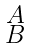Convert formula to latex. <formula><loc_0><loc_0><loc_500><loc_500>\begin{smallmatrix} A \\ B \end{smallmatrix}</formula> 